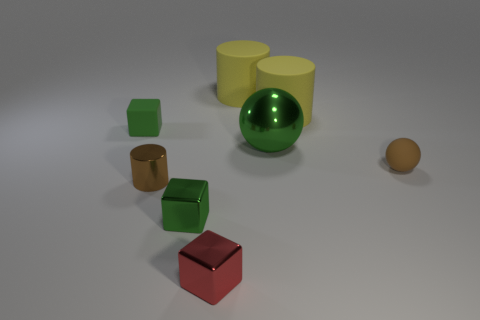Subtract all matte cylinders. How many cylinders are left? 1 Subtract all blue blocks. How many yellow cylinders are left? 2 Add 2 brown metallic cylinders. How many objects exist? 10 Subtract all balls. How many objects are left? 6 Subtract all yellow matte objects. Subtract all small brown balls. How many objects are left? 5 Add 1 balls. How many balls are left? 3 Add 1 yellow objects. How many yellow objects exist? 3 Subtract 1 red cubes. How many objects are left? 7 Subtract all yellow cubes. Subtract all blue balls. How many cubes are left? 3 